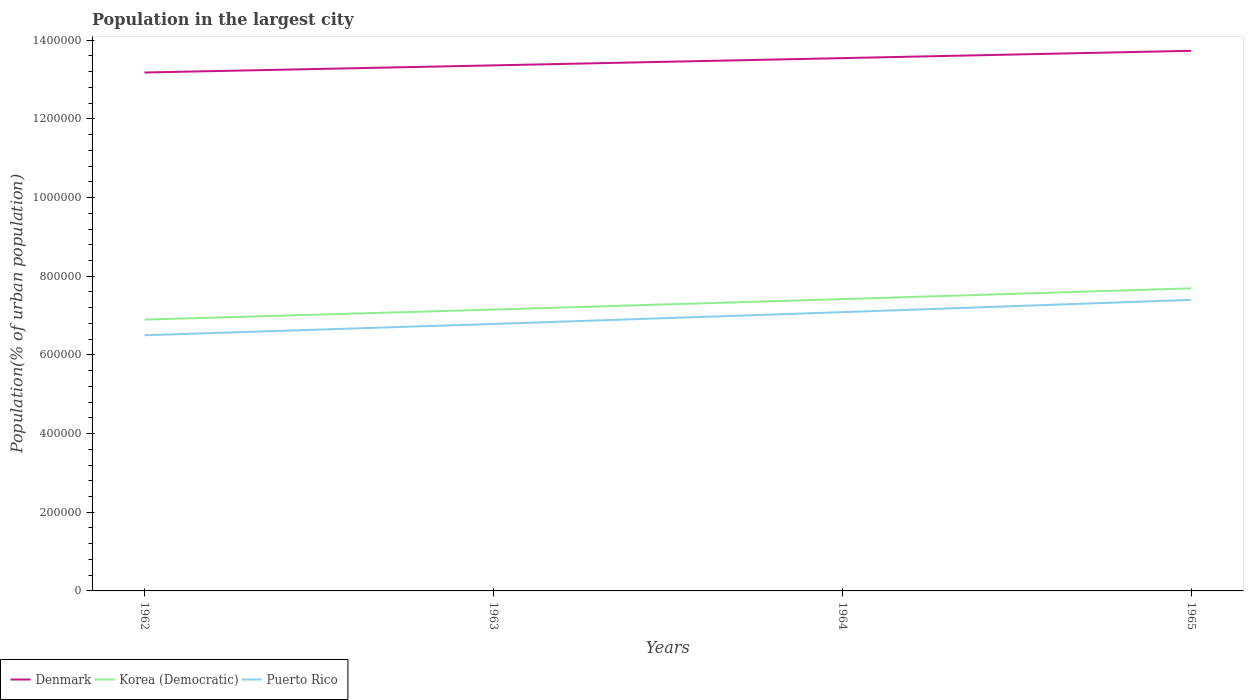Does the line corresponding to Puerto Rico intersect with the line corresponding to Korea (Democratic)?
Provide a short and direct response. No. Across all years, what is the maximum population in the largest city in Puerto Rico?
Keep it short and to the point. 6.50e+05. In which year was the population in the largest city in Puerto Rico maximum?
Keep it short and to the point. 1962. What is the total population in the largest city in Denmark in the graph?
Your response must be concise. -1.84e+04. What is the difference between the highest and the second highest population in the largest city in Puerto Rico?
Provide a succinct answer. 8.99e+04. What is the difference between the highest and the lowest population in the largest city in Puerto Rico?
Your answer should be very brief. 2. How many lines are there?
Offer a very short reply. 3. How many years are there in the graph?
Ensure brevity in your answer.  4. Does the graph contain grids?
Your answer should be compact. No. Where does the legend appear in the graph?
Ensure brevity in your answer.  Bottom left. How are the legend labels stacked?
Provide a short and direct response. Horizontal. What is the title of the graph?
Ensure brevity in your answer.  Population in the largest city. What is the label or title of the Y-axis?
Provide a succinct answer. Population(% of urban population). What is the Population(% of urban population) in Denmark in 1962?
Provide a short and direct response. 1.32e+06. What is the Population(% of urban population) of Korea (Democratic) in 1962?
Offer a very short reply. 6.90e+05. What is the Population(% of urban population) in Puerto Rico in 1962?
Offer a very short reply. 6.50e+05. What is the Population(% of urban population) in Denmark in 1963?
Make the answer very short. 1.34e+06. What is the Population(% of urban population) in Korea (Democratic) in 1963?
Your response must be concise. 7.15e+05. What is the Population(% of urban population) of Puerto Rico in 1963?
Provide a succinct answer. 6.79e+05. What is the Population(% of urban population) in Denmark in 1964?
Provide a succinct answer. 1.35e+06. What is the Population(% of urban population) in Korea (Democratic) in 1964?
Your answer should be very brief. 7.42e+05. What is the Population(% of urban population) of Puerto Rico in 1964?
Your response must be concise. 7.09e+05. What is the Population(% of urban population) in Denmark in 1965?
Your response must be concise. 1.37e+06. What is the Population(% of urban population) in Korea (Democratic) in 1965?
Your answer should be compact. 7.69e+05. What is the Population(% of urban population) in Puerto Rico in 1965?
Keep it short and to the point. 7.40e+05. Across all years, what is the maximum Population(% of urban population) of Denmark?
Make the answer very short. 1.37e+06. Across all years, what is the maximum Population(% of urban population) of Korea (Democratic)?
Keep it short and to the point. 7.69e+05. Across all years, what is the maximum Population(% of urban population) of Puerto Rico?
Provide a succinct answer. 7.40e+05. Across all years, what is the minimum Population(% of urban population) in Denmark?
Your answer should be compact. 1.32e+06. Across all years, what is the minimum Population(% of urban population) in Korea (Democratic)?
Make the answer very short. 6.90e+05. Across all years, what is the minimum Population(% of urban population) in Puerto Rico?
Offer a very short reply. 6.50e+05. What is the total Population(% of urban population) in Denmark in the graph?
Provide a succinct answer. 5.38e+06. What is the total Population(% of urban population) of Korea (Democratic) in the graph?
Ensure brevity in your answer.  2.92e+06. What is the total Population(% of urban population) of Puerto Rico in the graph?
Offer a very short reply. 2.78e+06. What is the difference between the Population(% of urban population) of Denmark in 1962 and that in 1963?
Give a very brief answer. -1.82e+04. What is the difference between the Population(% of urban population) of Korea (Democratic) in 1962 and that in 1963?
Your answer should be very brief. -2.56e+04. What is the difference between the Population(% of urban population) of Puerto Rico in 1962 and that in 1963?
Provide a short and direct response. -2.87e+04. What is the difference between the Population(% of urban population) of Denmark in 1962 and that in 1964?
Give a very brief answer. -3.66e+04. What is the difference between the Population(% of urban population) in Korea (Democratic) in 1962 and that in 1964?
Ensure brevity in your answer.  -5.21e+04. What is the difference between the Population(% of urban population) of Puerto Rico in 1962 and that in 1964?
Provide a short and direct response. -5.87e+04. What is the difference between the Population(% of urban population) in Denmark in 1962 and that in 1965?
Give a very brief answer. -5.52e+04. What is the difference between the Population(% of urban population) of Korea (Democratic) in 1962 and that in 1965?
Provide a succinct answer. -7.95e+04. What is the difference between the Population(% of urban population) of Puerto Rico in 1962 and that in 1965?
Provide a succinct answer. -8.99e+04. What is the difference between the Population(% of urban population) in Denmark in 1963 and that in 1964?
Provide a short and direct response. -1.84e+04. What is the difference between the Population(% of urban population) in Korea (Democratic) in 1963 and that in 1964?
Keep it short and to the point. -2.65e+04. What is the difference between the Population(% of urban population) in Puerto Rico in 1963 and that in 1964?
Provide a succinct answer. -3.00e+04. What is the difference between the Population(% of urban population) of Denmark in 1963 and that in 1965?
Offer a very short reply. -3.71e+04. What is the difference between the Population(% of urban population) of Korea (Democratic) in 1963 and that in 1965?
Provide a succinct answer. -5.40e+04. What is the difference between the Population(% of urban population) in Puerto Rico in 1963 and that in 1965?
Offer a terse response. -6.12e+04. What is the difference between the Population(% of urban population) in Denmark in 1964 and that in 1965?
Your answer should be very brief. -1.86e+04. What is the difference between the Population(% of urban population) in Korea (Democratic) in 1964 and that in 1965?
Your answer should be compact. -2.74e+04. What is the difference between the Population(% of urban population) of Puerto Rico in 1964 and that in 1965?
Provide a succinct answer. -3.12e+04. What is the difference between the Population(% of urban population) of Denmark in 1962 and the Population(% of urban population) of Korea (Democratic) in 1963?
Your response must be concise. 6.03e+05. What is the difference between the Population(% of urban population) of Denmark in 1962 and the Population(% of urban population) of Puerto Rico in 1963?
Provide a short and direct response. 6.39e+05. What is the difference between the Population(% of urban population) of Korea (Democratic) in 1962 and the Population(% of urban population) of Puerto Rico in 1963?
Your response must be concise. 1.10e+04. What is the difference between the Population(% of urban population) in Denmark in 1962 and the Population(% of urban population) in Korea (Democratic) in 1964?
Provide a succinct answer. 5.76e+05. What is the difference between the Population(% of urban population) in Denmark in 1962 and the Population(% of urban population) in Puerto Rico in 1964?
Provide a succinct answer. 6.09e+05. What is the difference between the Population(% of urban population) of Korea (Democratic) in 1962 and the Population(% of urban population) of Puerto Rico in 1964?
Ensure brevity in your answer.  -1.90e+04. What is the difference between the Population(% of urban population) of Denmark in 1962 and the Population(% of urban population) of Korea (Democratic) in 1965?
Offer a terse response. 5.49e+05. What is the difference between the Population(% of urban population) in Denmark in 1962 and the Population(% of urban population) in Puerto Rico in 1965?
Your response must be concise. 5.78e+05. What is the difference between the Population(% of urban population) of Korea (Democratic) in 1962 and the Population(% of urban population) of Puerto Rico in 1965?
Make the answer very short. -5.02e+04. What is the difference between the Population(% of urban population) of Denmark in 1963 and the Population(% of urban population) of Korea (Democratic) in 1964?
Provide a short and direct response. 5.94e+05. What is the difference between the Population(% of urban population) of Denmark in 1963 and the Population(% of urban population) of Puerto Rico in 1964?
Keep it short and to the point. 6.27e+05. What is the difference between the Population(% of urban population) of Korea (Democratic) in 1963 and the Population(% of urban population) of Puerto Rico in 1964?
Your answer should be very brief. 6601. What is the difference between the Population(% of urban population) in Denmark in 1963 and the Population(% of urban population) in Korea (Democratic) in 1965?
Offer a very short reply. 5.67e+05. What is the difference between the Population(% of urban population) of Denmark in 1963 and the Population(% of urban population) of Puerto Rico in 1965?
Your answer should be compact. 5.96e+05. What is the difference between the Population(% of urban population) in Korea (Democratic) in 1963 and the Population(% of urban population) in Puerto Rico in 1965?
Make the answer very short. -2.46e+04. What is the difference between the Population(% of urban population) in Denmark in 1964 and the Population(% of urban population) in Korea (Democratic) in 1965?
Offer a very short reply. 5.85e+05. What is the difference between the Population(% of urban population) of Denmark in 1964 and the Population(% of urban population) of Puerto Rico in 1965?
Offer a terse response. 6.15e+05. What is the difference between the Population(% of urban population) of Korea (Democratic) in 1964 and the Population(% of urban population) of Puerto Rico in 1965?
Your answer should be compact. 1922. What is the average Population(% of urban population) of Denmark per year?
Provide a short and direct response. 1.35e+06. What is the average Population(% of urban population) of Korea (Democratic) per year?
Give a very brief answer. 7.29e+05. What is the average Population(% of urban population) of Puerto Rico per year?
Offer a terse response. 6.94e+05. In the year 1962, what is the difference between the Population(% of urban population) in Denmark and Population(% of urban population) in Korea (Democratic)?
Provide a succinct answer. 6.28e+05. In the year 1962, what is the difference between the Population(% of urban population) of Denmark and Population(% of urban population) of Puerto Rico?
Your answer should be very brief. 6.68e+05. In the year 1962, what is the difference between the Population(% of urban population) in Korea (Democratic) and Population(% of urban population) in Puerto Rico?
Offer a very short reply. 3.97e+04. In the year 1963, what is the difference between the Population(% of urban population) of Denmark and Population(% of urban population) of Korea (Democratic)?
Your answer should be compact. 6.21e+05. In the year 1963, what is the difference between the Population(% of urban population) of Denmark and Population(% of urban population) of Puerto Rico?
Provide a short and direct response. 6.57e+05. In the year 1963, what is the difference between the Population(% of urban population) in Korea (Democratic) and Population(% of urban population) in Puerto Rico?
Provide a succinct answer. 3.66e+04. In the year 1964, what is the difference between the Population(% of urban population) in Denmark and Population(% of urban population) in Korea (Democratic)?
Ensure brevity in your answer.  6.13e+05. In the year 1964, what is the difference between the Population(% of urban population) in Denmark and Population(% of urban population) in Puerto Rico?
Your answer should be very brief. 6.46e+05. In the year 1964, what is the difference between the Population(% of urban population) in Korea (Democratic) and Population(% of urban population) in Puerto Rico?
Offer a very short reply. 3.31e+04. In the year 1965, what is the difference between the Population(% of urban population) in Denmark and Population(% of urban population) in Korea (Democratic)?
Make the answer very short. 6.04e+05. In the year 1965, what is the difference between the Population(% of urban population) in Denmark and Population(% of urban population) in Puerto Rico?
Give a very brief answer. 6.33e+05. In the year 1965, what is the difference between the Population(% of urban population) in Korea (Democratic) and Population(% of urban population) in Puerto Rico?
Keep it short and to the point. 2.94e+04. What is the ratio of the Population(% of urban population) of Denmark in 1962 to that in 1963?
Make the answer very short. 0.99. What is the ratio of the Population(% of urban population) of Korea (Democratic) in 1962 to that in 1963?
Your answer should be compact. 0.96. What is the ratio of the Population(% of urban population) in Puerto Rico in 1962 to that in 1963?
Your answer should be very brief. 0.96. What is the ratio of the Population(% of urban population) of Korea (Democratic) in 1962 to that in 1964?
Offer a very short reply. 0.93. What is the ratio of the Population(% of urban population) of Puerto Rico in 1962 to that in 1964?
Keep it short and to the point. 0.92. What is the ratio of the Population(% of urban population) of Denmark in 1962 to that in 1965?
Provide a short and direct response. 0.96. What is the ratio of the Population(% of urban population) in Korea (Democratic) in 1962 to that in 1965?
Your answer should be compact. 0.9. What is the ratio of the Population(% of urban population) of Puerto Rico in 1962 to that in 1965?
Your answer should be compact. 0.88. What is the ratio of the Population(% of urban population) in Denmark in 1963 to that in 1964?
Make the answer very short. 0.99. What is the ratio of the Population(% of urban population) of Korea (Democratic) in 1963 to that in 1964?
Ensure brevity in your answer.  0.96. What is the ratio of the Population(% of urban population) of Puerto Rico in 1963 to that in 1964?
Ensure brevity in your answer.  0.96. What is the ratio of the Population(% of urban population) of Korea (Democratic) in 1963 to that in 1965?
Make the answer very short. 0.93. What is the ratio of the Population(% of urban population) of Puerto Rico in 1963 to that in 1965?
Make the answer very short. 0.92. What is the ratio of the Population(% of urban population) of Denmark in 1964 to that in 1965?
Ensure brevity in your answer.  0.99. What is the ratio of the Population(% of urban population) of Korea (Democratic) in 1964 to that in 1965?
Provide a short and direct response. 0.96. What is the ratio of the Population(% of urban population) of Puerto Rico in 1964 to that in 1965?
Offer a terse response. 0.96. What is the difference between the highest and the second highest Population(% of urban population) of Denmark?
Offer a very short reply. 1.86e+04. What is the difference between the highest and the second highest Population(% of urban population) in Korea (Democratic)?
Provide a succinct answer. 2.74e+04. What is the difference between the highest and the second highest Population(% of urban population) in Puerto Rico?
Your answer should be compact. 3.12e+04. What is the difference between the highest and the lowest Population(% of urban population) of Denmark?
Make the answer very short. 5.52e+04. What is the difference between the highest and the lowest Population(% of urban population) of Korea (Democratic)?
Your response must be concise. 7.95e+04. What is the difference between the highest and the lowest Population(% of urban population) of Puerto Rico?
Your answer should be compact. 8.99e+04. 